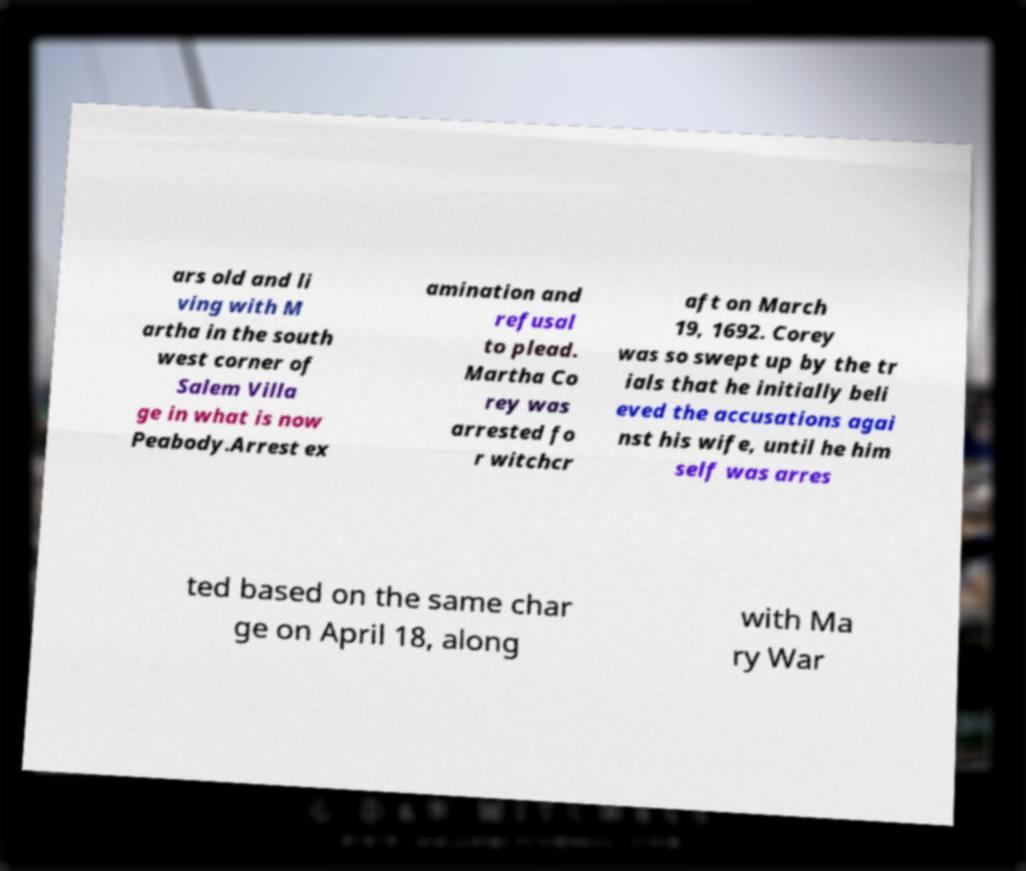There's text embedded in this image that I need extracted. Can you transcribe it verbatim? ars old and li ving with M artha in the south west corner of Salem Villa ge in what is now Peabody.Arrest ex amination and refusal to plead. Martha Co rey was arrested fo r witchcr aft on March 19, 1692. Corey was so swept up by the tr ials that he initially beli eved the accusations agai nst his wife, until he him self was arres ted based on the same char ge on April 18, along with Ma ry War 